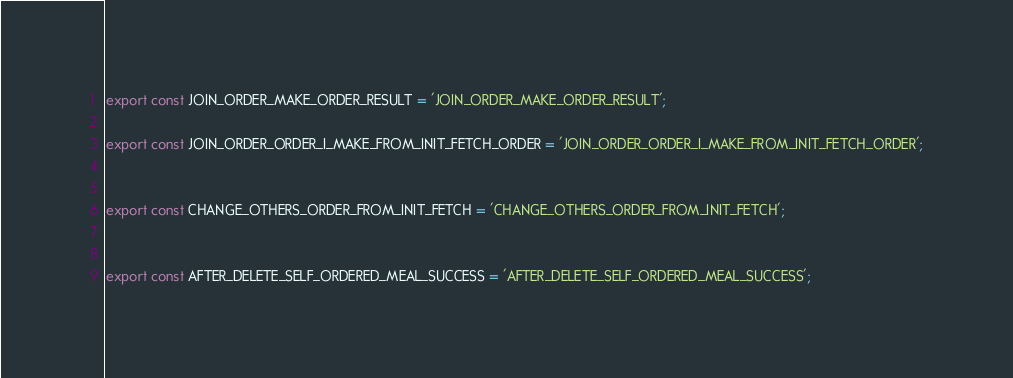Convert code to text. <code><loc_0><loc_0><loc_500><loc_500><_JavaScript_>
export const JOIN_ORDER_MAKE_ORDER_RESULT = 'JOIN_ORDER_MAKE_ORDER_RESULT';

export const JOIN_ORDER_ORDER_I_MAKE_FROM_INIT_FETCH_ORDER = 'JOIN_ORDER_ORDER_I_MAKE_FROM_INIT_FETCH_ORDER';


export const CHANGE_OTHERS_ORDER_FROM_INIT_FETCH = 'CHANGE_OTHERS_ORDER_FROM_INIT_FETCH';


export const AFTER_DELETE_SELF_ORDERED_MEAL_SUCCESS = 'AFTER_DELETE_SELF_ORDERED_MEAL_SUCCESS';</code> 